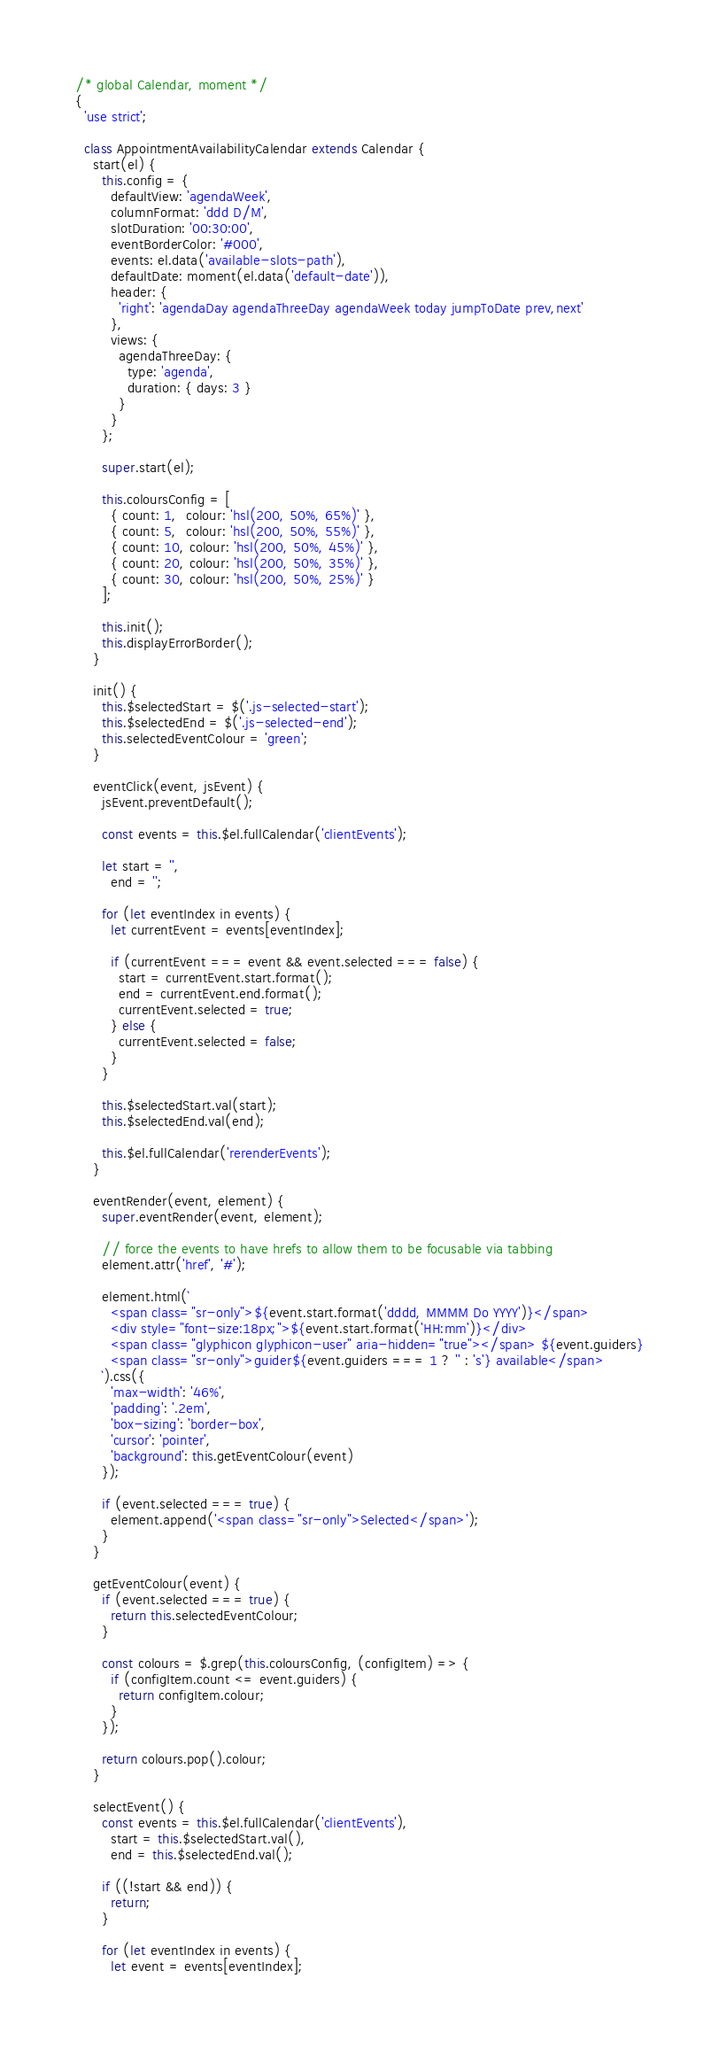<code> <loc_0><loc_0><loc_500><loc_500><_JavaScript_>/* global Calendar, moment */
{
  'use strict';

  class AppointmentAvailabilityCalendar extends Calendar {
    start(el) {
      this.config = {
        defaultView: 'agendaWeek',
        columnFormat: 'ddd D/M',
        slotDuration: '00:30:00',
        eventBorderColor: '#000',
        events: el.data('available-slots-path'),
        defaultDate: moment(el.data('default-date')),
        header: {
          'right': 'agendaDay agendaThreeDay agendaWeek today jumpToDate prev,next'
        },
        views: {
          agendaThreeDay: {
            type: 'agenda',
            duration: { days: 3 }
          }
        }
      };

      super.start(el);

      this.coloursConfig = [
        { count: 1,  colour: 'hsl(200, 50%, 65%)' },
        { count: 5,  colour: 'hsl(200, 50%, 55%)' },
        { count: 10, colour: 'hsl(200, 50%, 45%)' },
        { count: 20, colour: 'hsl(200, 50%, 35%)' },
        { count: 30, colour: 'hsl(200, 50%, 25%)' }
      ];

      this.init();
      this.displayErrorBorder();
    }

    init() {
      this.$selectedStart = $('.js-selected-start');
      this.$selectedEnd = $('.js-selected-end');
      this.selectedEventColour = 'green';
    }

    eventClick(event, jsEvent) {
      jsEvent.preventDefault();

      const events = this.$el.fullCalendar('clientEvents');

      let start = '',
        end = '';

      for (let eventIndex in events) {
        let currentEvent = events[eventIndex];

        if (currentEvent === event && event.selected === false) {
          start = currentEvent.start.format();
          end = currentEvent.end.format();
          currentEvent.selected = true;
        } else {
          currentEvent.selected = false;
        }
      }

      this.$selectedStart.val(start);
      this.$selectedEnd.val(end);

      this.$el.fullCalendar('rerenderEvents');
    }

    eventRender(event, element) {
      super.eventRender(event, element);

      // force the events to have hrefs to allow them to be focusable via tabbing
      element.attr('href', '#');

      element.html(`
        <span class="sr-only">${event.start.format('dddd, MMMM Do YYYY')}</span>
        <div style="font-size:18px;">${event.start.format('HH:mm')}</div>
        <span class="glyphicon glyphicon-user" aria-hidden="true"></span> ${event.guiders}
        <span class="sr-only">guider${event.guiders === 1 ? '' : 's'} available</span>
      `).css({
        'max-width': '46%',
        'padding': '.2em',
        'box-sizing': 'border-box',
        'cursor': 'pointer',
        'background': this.getEventColour(event)
      });

      if (event.selected === true) {
        element.append('<span class="sr-only">Selected</span>');
      }
    }

    getEventColour(event) {
      if (event.selected === true) {
        return this.selectedEventColour;
      }

      const colours = $.grep(this.coloursConfig, (configItem) => {
        if (configItem.count <= event.guiders) {
          return configItem.colour;
        }
      });

      return colours.pop().colour;
    }

    selectEvent() {
      const events = this.$el.fullCalendar('clientEvents'),
        start = this.$selectedStart.val(),
        end = this.$selectedEnd.val();

      if ((!start && end)) {
        return;
      }

      for (let eventIndex in events) {
        let event = events[eventIndex];
</code> 